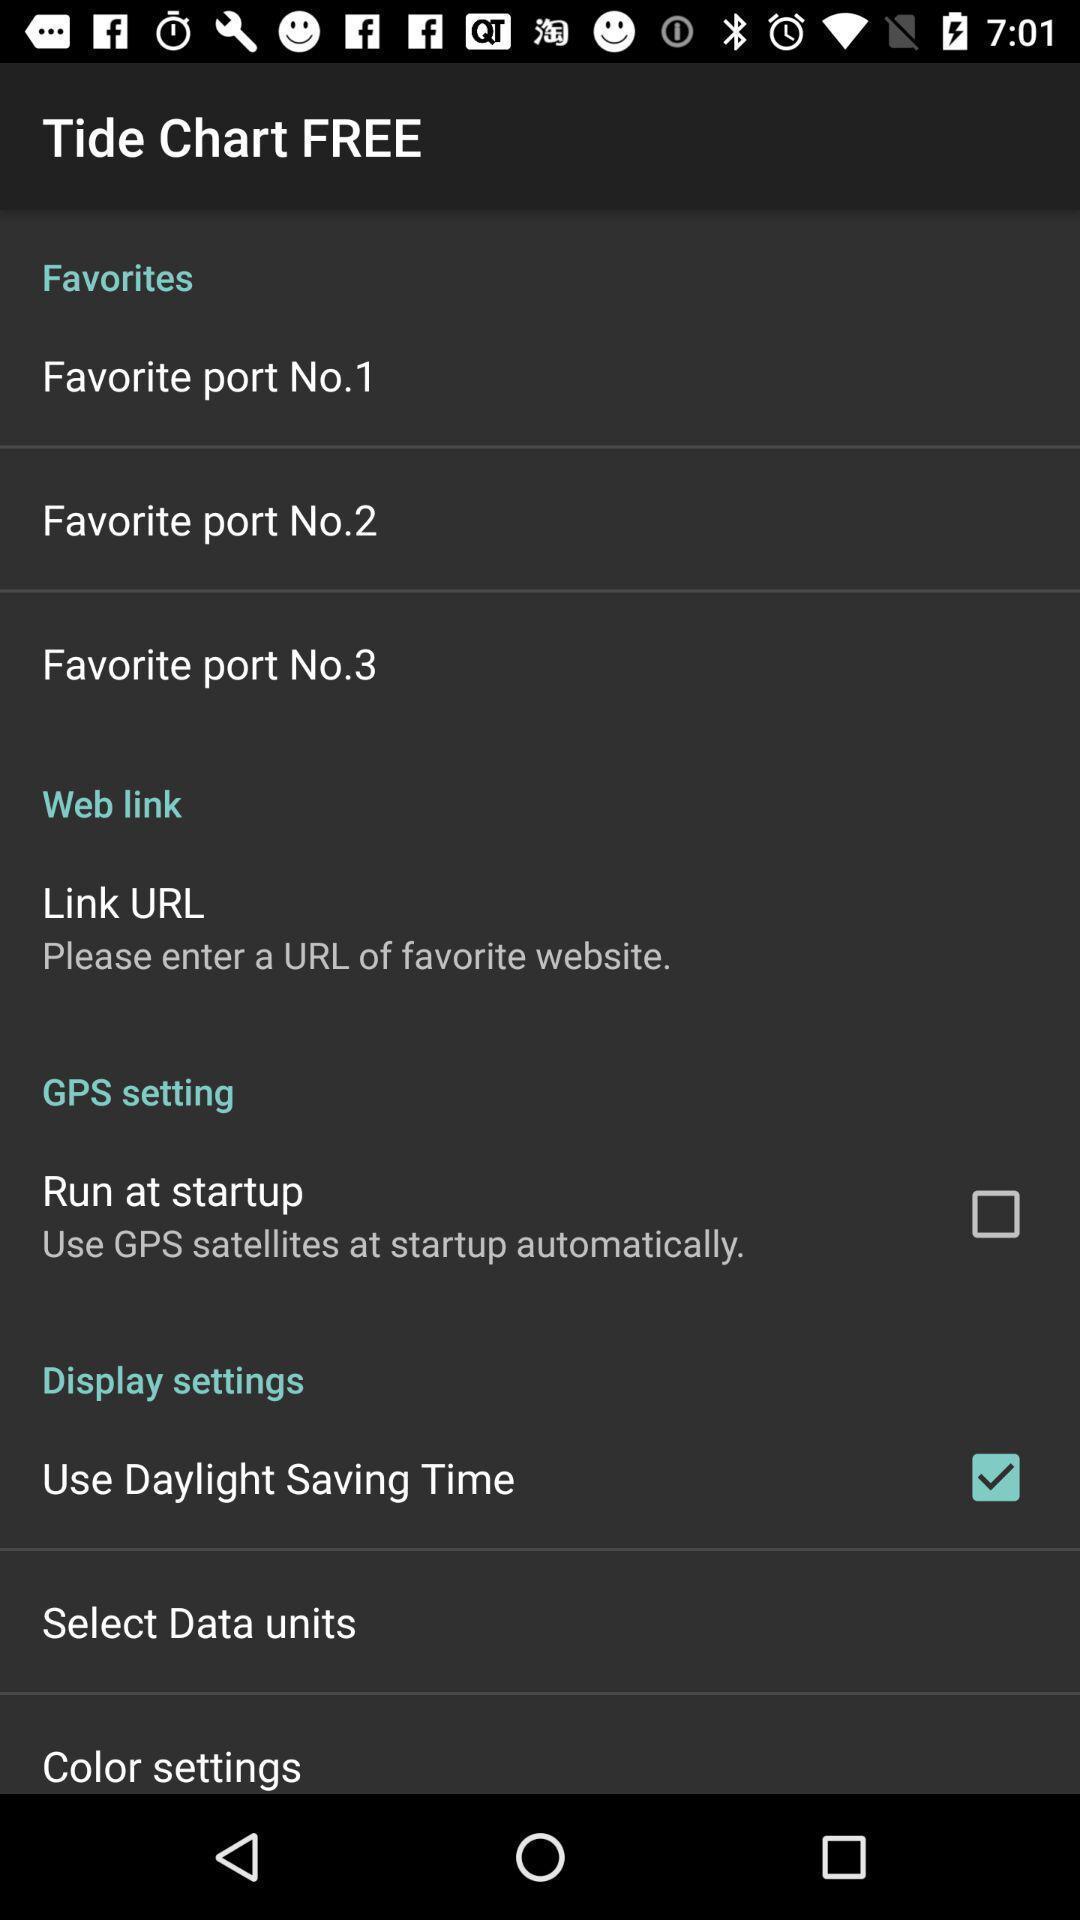Please provide a description for this image. Screen shows different options for tidal information. 